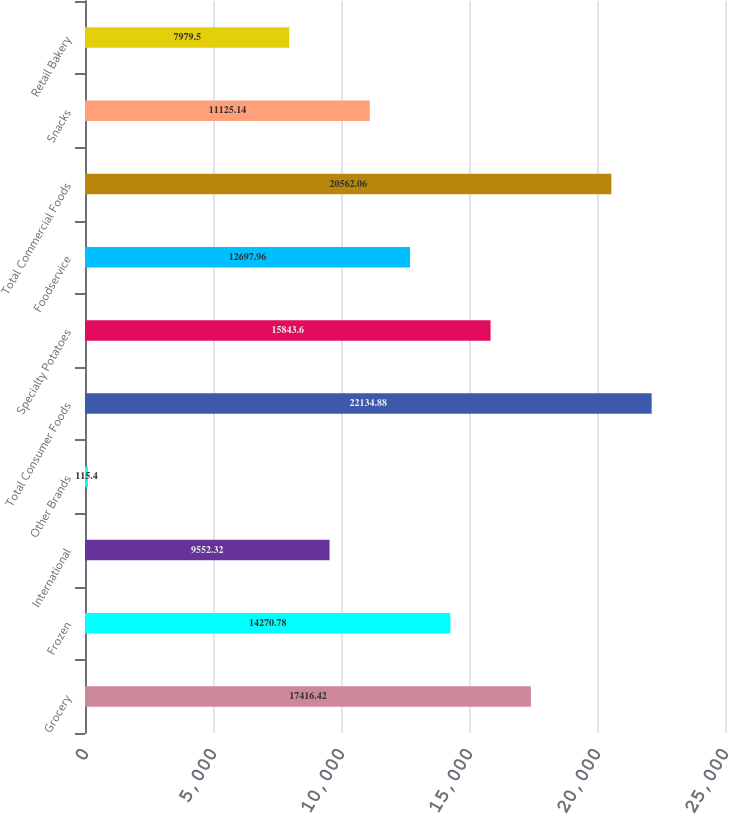Convert chart. <chart><loc_0><loc_0><loc_500><loc_500><bar_chart><fcel>Grocery<fcel>Frozen<fcel>International<fcel>Other Brands<fcel>Total Consumer Foods<fcel>Specialty Potatoes<fcel>Foodservice<fcel>Total Commercial Foods<fcel>Snacks<fcel>Retail Bakery<nl><fcel>17416.4<fcel>14270.8<fcel>9552.32<fcel>115.4<fcel>22134.9<fcel>15843.6<fcel>12698<fcel>20562.1<fcel>11125.1<fcel>7979.5<nl></chart> 